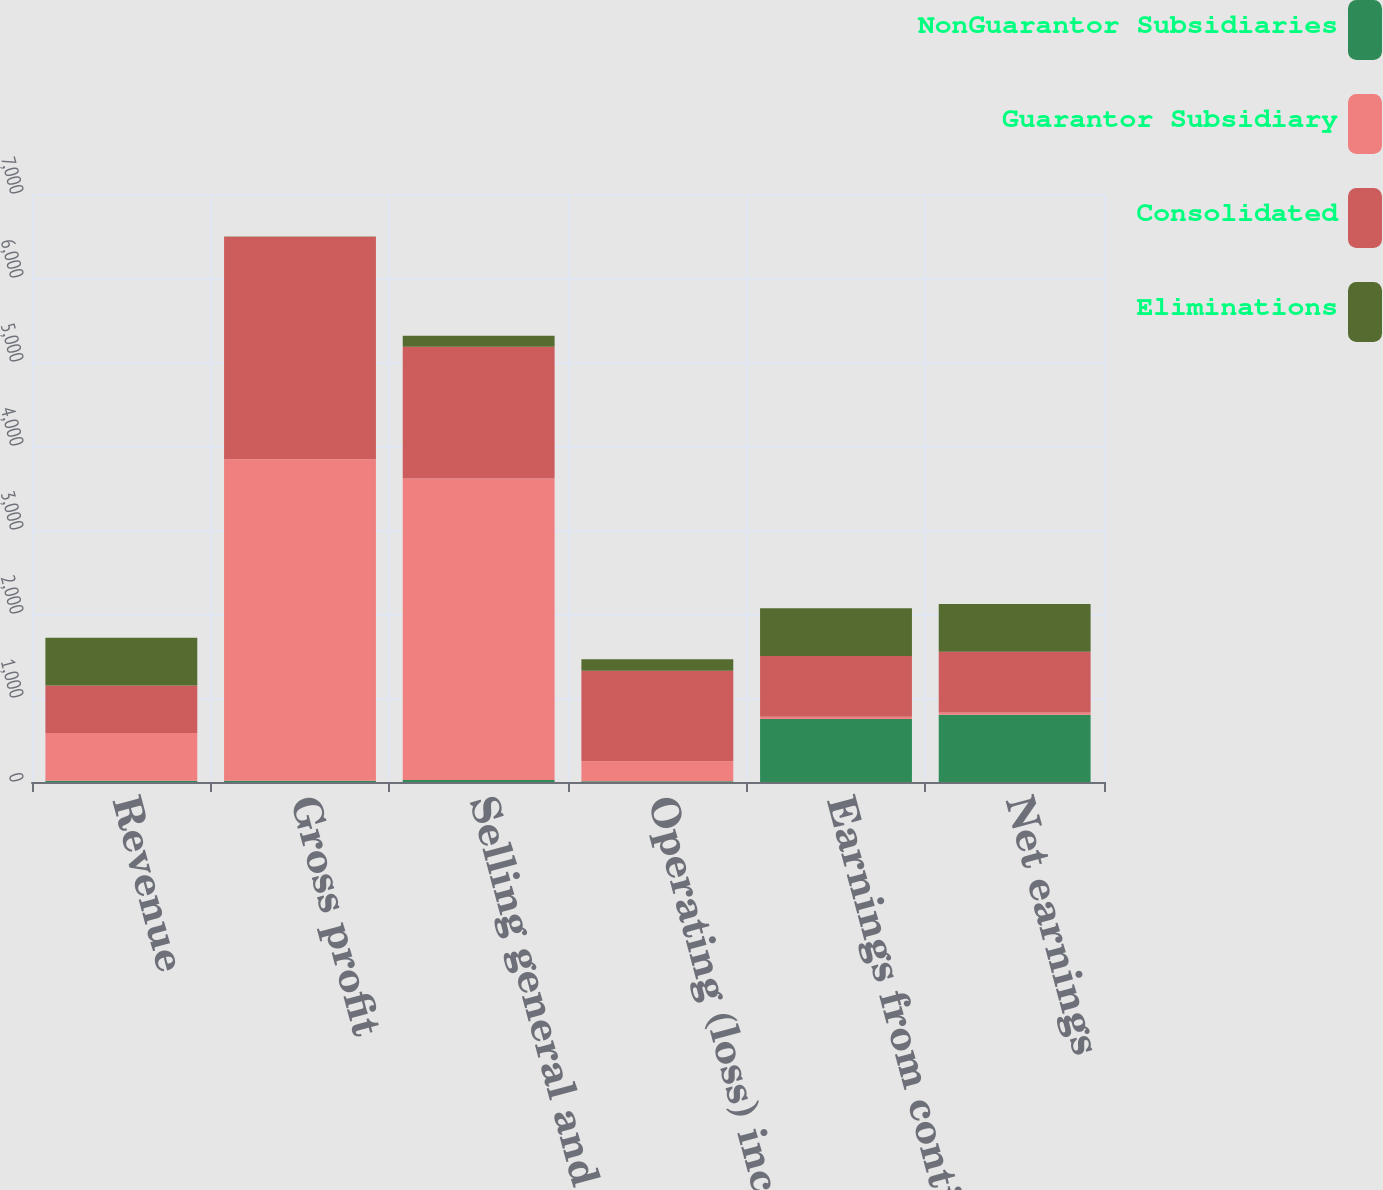Convert chart to OTSL. <chart><loc_0><loc_0><loc_500><loc_500><stacked_bar_chart><ecel><fcel>Revenue<fcel>Gross profit<fcel>Selling general and<fcel>Operating (loss) income<fcel>Earnings from continuing<fcel>Net earnings<nl><fcel>NonGuarantor Subsidiaries<fcel>16<fcel>16<fcel>25<fcel>9<fcel>750<fcel>800<nl><fcel>Guarantor Subsidiary<fcel>567<fcel>3825<fcel>3587<fcel>238<fcel>28<fcel>28<nl><fcel>Consolidated<fcel>567<fcel>2649<fcel>1571<fcel>1078<fcel>723<fcel>723<nl><fcel>Eliminations<fcel>567<fcel>5<fcel>130<fcel>135<fcel>567<fcel>567<nl></chart> 